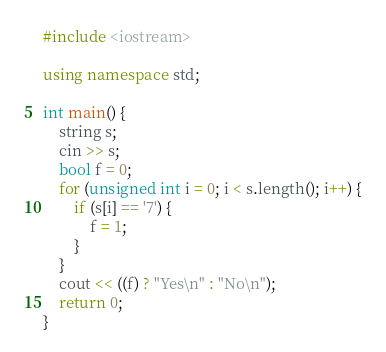<code> <loc_0><loc_0><loc_500><loc_500><_C++_>#include <iostream>

using namespace std;

int main() {
	string s;
	cin >> s;
	bool f = 0;
	for (unsigned int i = 0; i < s.length(); i++) {
		if (s[i] == '7') {
			f = 1;
		}
	}
	cout << ((f) ? "Yes\n" : "No\n");
	return 0;
}
</code> 